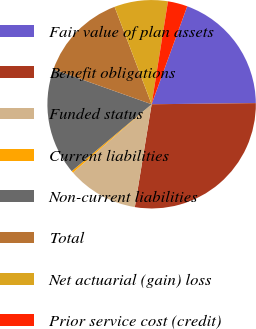<chart> <loc_0><loc_0><loc_500><loc_500><pie_chart><fcel>Fair value of plan assets<fcel>Benefit obligations<fcel>Funded status<fcel>Current liabilities<fcel>Non-current liabilities<fcel>Total<fcel>Net actuarial (gain) loss<fcel>Prior service cost (credit)<nl><fcel>19.28%<fcel>27.75%<fcel>11.04%<fcel>0.29%<fcel>16.53%<fcel>13.78%<fcel>8.29%<fcel>3.04%<nl></chart> 